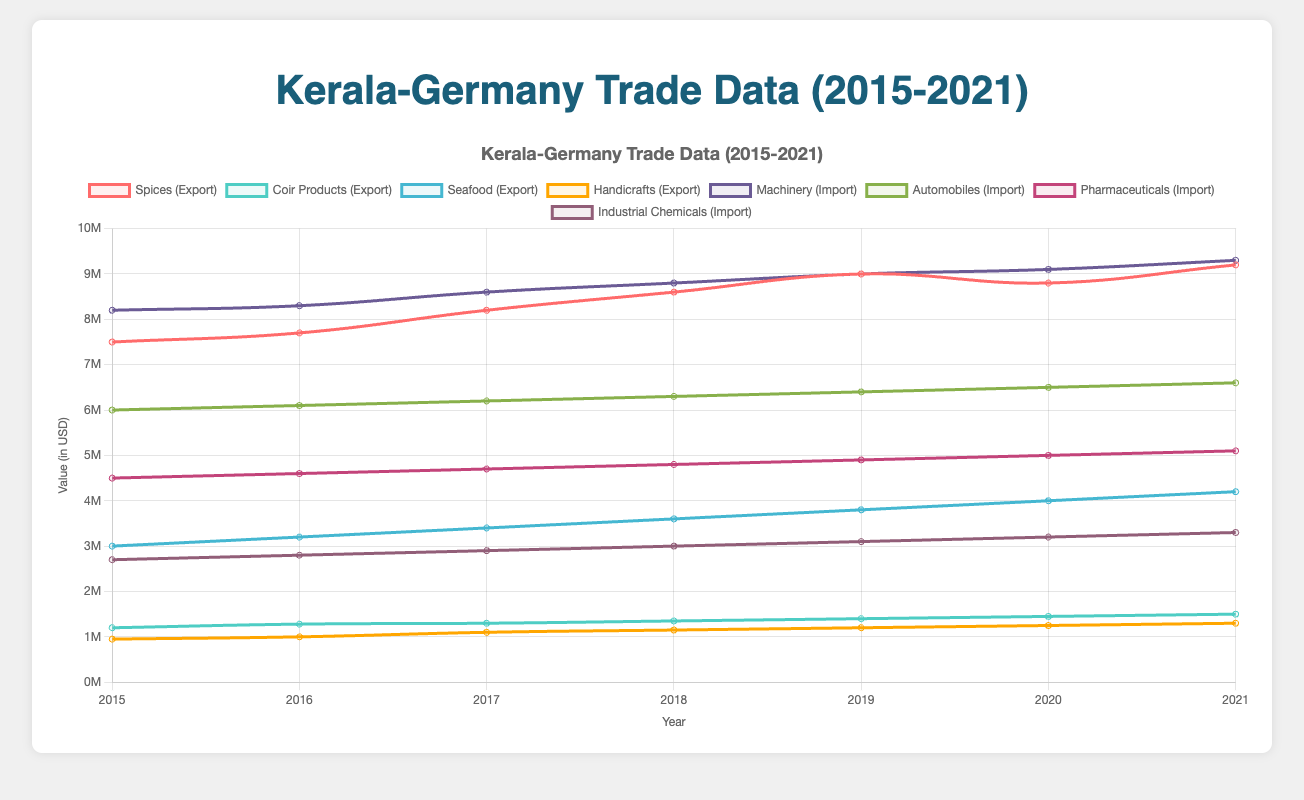Which product has the highest export value in 2021? Look for the highest data point in 2021 among the export product lines. The spices have the highest value.
Answer: Spices Which year did automobiles have the lowest import value? Check the data points for automobiles each year to identify the year with the lowest value. In 2015, it is the lowest.
Answer: 2015 What is the total export value of spices over the years presented? Sum the export values for spices from 2015 to 2021: 7500000 + 7700000 + 8200000 + 8600000 + 9000000 + 8800000 + 9200000.
Answer: 59000000 How much did the export value of seafood change from 2015 to 2021? Calculate the difference in seafood export values from 2015 to 2021: 4200000 - 3000000.
Answer: 1200000 Compare the import values of pharmaceuticals and machinery in 2020. Which one is higher, and by how much? Subtract the import values of pharmaceuticals from machinery in 2020: 9100000 - 5000000.
Answer: Machinery by 4100000 What was the average yearly export value of handicrafts from 2015 to 2021? Sum the export values of handicrafts for each year and divide by the number of years: (950000 + 1000000 + 1100000 + 1150000 + 1200000 + 1250000 + 1300000) / 7.
Answer: 1135714.29 Between 2015 and 2021, in which year did the import of industrial chemicals see the highest increase compared to the previous year? Calculate the yearly increase for industrial chemicals and find the highest: 2016 (+100000), 2017 (+100000), 2018 (+100000), 2019 (+100000), 2020 (+100000), 2021 (+100000). They are all equal.
Answer: None What is the sum of coir products export values and automobiles import values in 2019? Add the export value of coir products with the import value of automobiles in 2019: 1400000 + 6400000.
Answer: 7800000 Which product had a steady growth in export value from 2015 to 2021? Visually assess the export lines and identify the one with a consistent increase each year. Coir products had a steady growth.
Answer: Coir products What is the difference between the highest and lowest export values of spices from 2015 to 2021? Subtract the lowest export value from the highest for spices: 9200000 - 7500000.
Answer: 1700000 